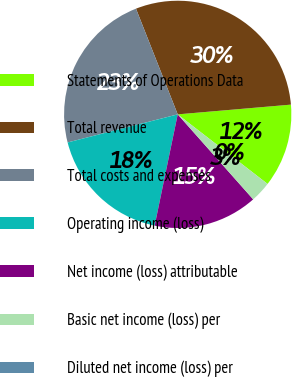Convert chart. <chart><loc_0><loc_0><loc_500><loc_500><pie_chart><fcel>Statements of Operations Data<fcel>Total revenue<fcel>Total costs and expenses<fcel>Operating income (loss)<fcel>Net income (loss) attributable<fcel>Basic net income (loss) per<fcel>Diluted net income (loss) per<nl><fcel>11.85%<fcel>29.62%<fcel>22.99%<fcel>17.77%<fcel>14.81%<fcel>2.96%<fcel>0.0%<nl></chart> 